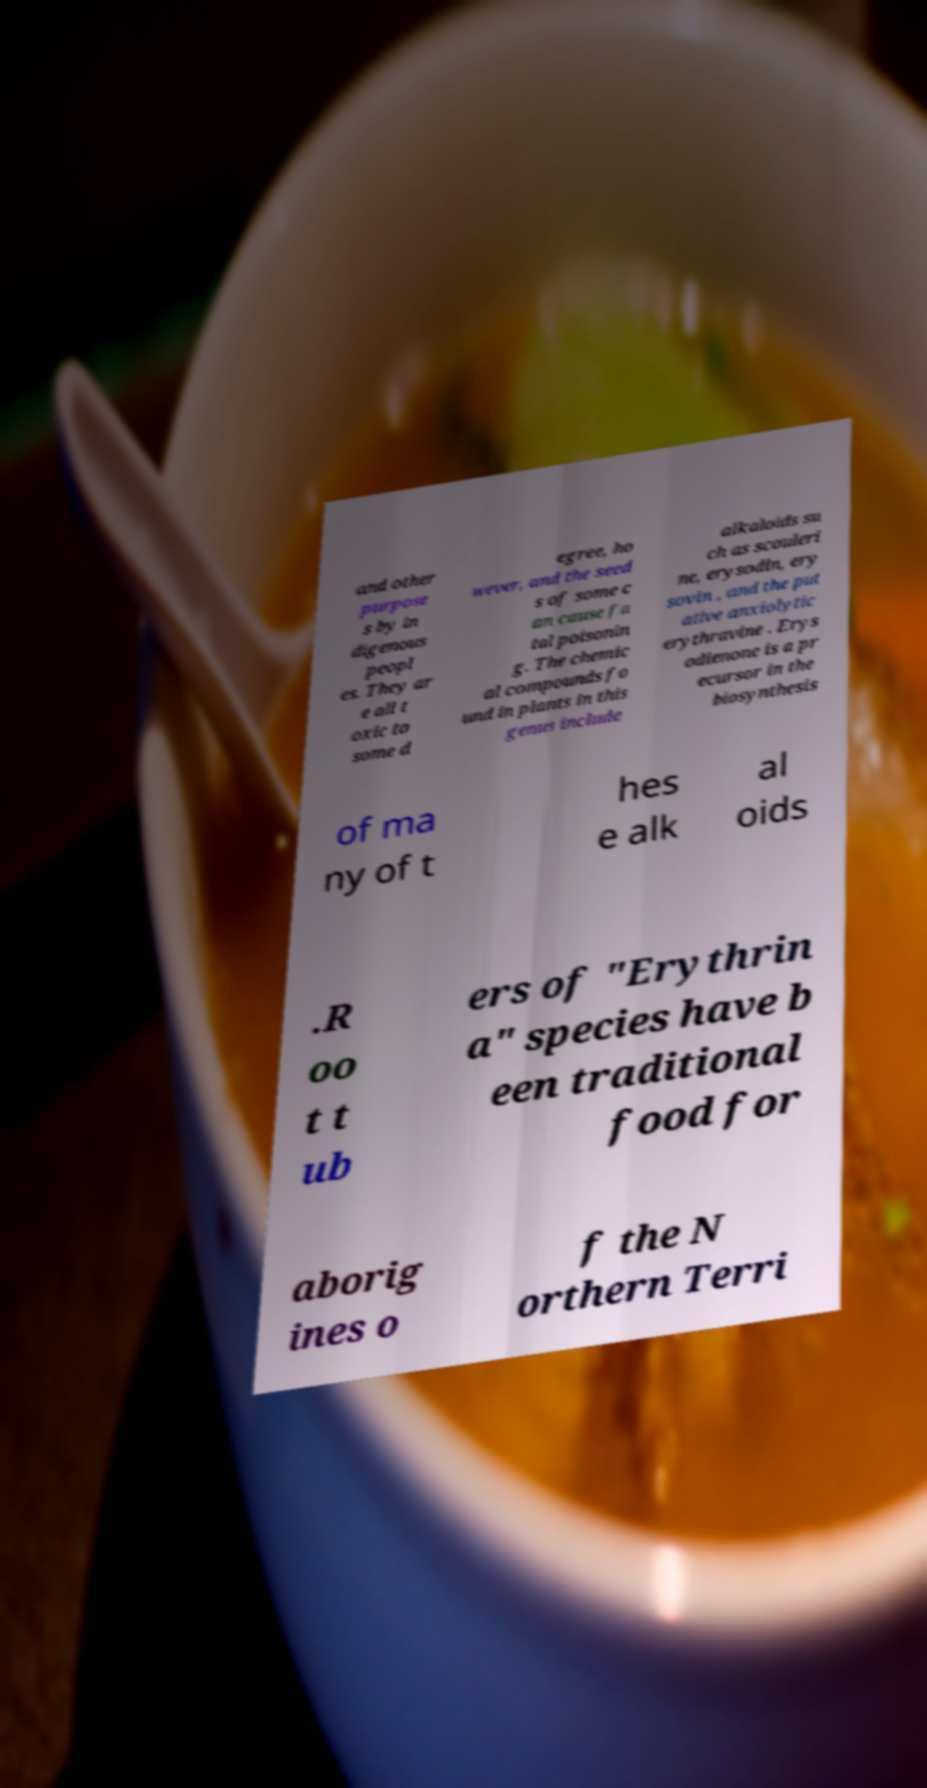There's text embedded in this image that I need extracted. Can you transcribe it verbatim? and other purpose s by in digenous peopl es. They ar e all t oxic to some d egree, ho wever, and the seed s of some c an cause fa tal poisonin g. The chemic al compounds fo und in plants in this genus include alkaloids su ch as scouleri ne, erysodin, ery sovin , and the put ative anxiolytic erythravine . Erys odienone is a pr ecursor in the biosynthesis of ma ny of t hes e alk al oids .R oo t t ub ers of "Erythrin a" species have b een traditional food for aborig ines o f the N orthern Terri 